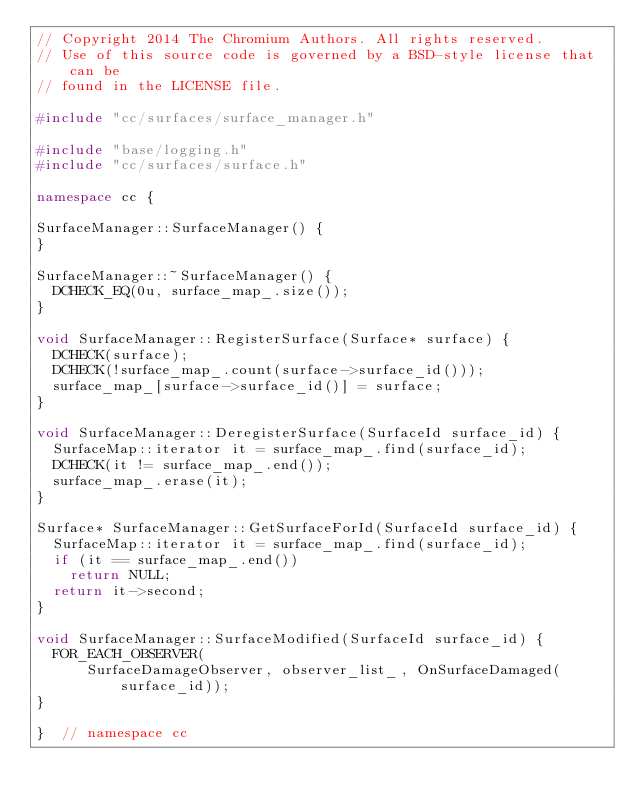<code> <loc_0><loc_0><loc_500><loc_500><_C++_>// Copyright 2014 The Chromium Authors. All rights reserved.
// Use of this source code is governed by a BSD-style license that can be
// found in the LICENSE file.

#include "cc/surfaces/surface_manager.h"

#include "base/logging.h"
#include "cc/surfaces/surface.h"

namespace cc {

SurfaceManager::SurfaceManager() {
}

SurfaceManager::~SurfaceManager() {
  DCHECK_EQ(0u, surface_map_.size());
}

void SurfaceManager::RegisterSurface(Surface* surface) {
  DCHECK(surface);
  DCHECK(!surface_map_.count(surface->surface_id()));
  surface_map_[surface->surface_id()] = surface;
}

void SurfaceManager::DeregisterSurface(SurfaceId surface_id) {
  SurfaceMap::iterator it = surface_map_.find(surface_id);
  DCHECK(it != surface_map_.end());
  surface_map_.erase(it);
}

Surface* SurfaceManager::GetSurfaceForId(SurfaceId surface_id) {
  SurfaceMap::iterator it = surface_map_.find(surface_id);
  if (it == surface_map_.end())
    return NULL;
  return it->second;
}

void SurfaceManager::SurfaceModified(SurfaceId surface_id) {
  FOR_EACH_OBSERVER(
      SurfaceDamageObserver, observer_list_, OnSurfaceDamaged(surface_id));
}

}  // namespace cc
</code> 